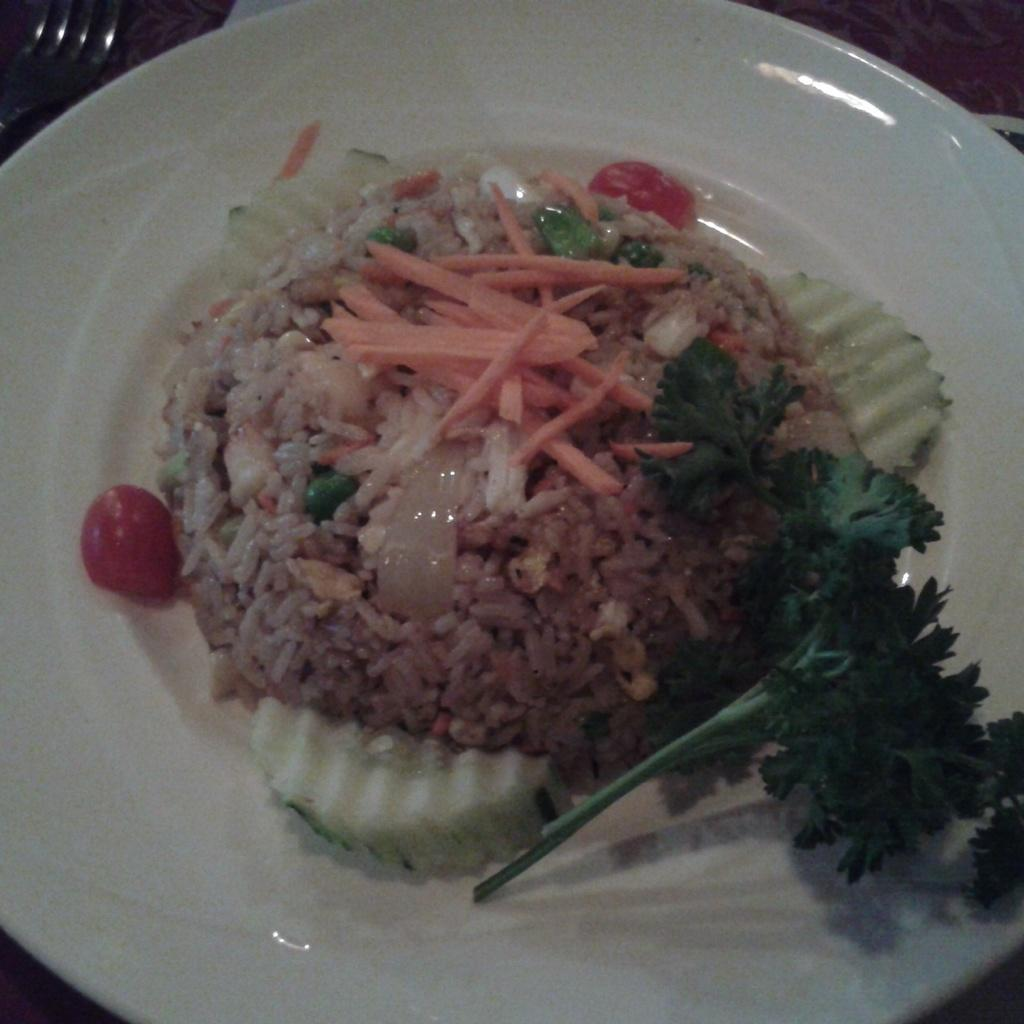What is present on the plate in the image? There are food items served on the plate in the image. Can you describe the food items on the plate? Unfortunately, the specific food items cannot be determined from the given facts. What might someone do with the food items on the plate? Someone might eat the food items on the plate. How does the beginner learn to use their muscles during recess in the image? There is no reference to a beginner, muscles, or recess in the image, so it is not possible to answer that question. 